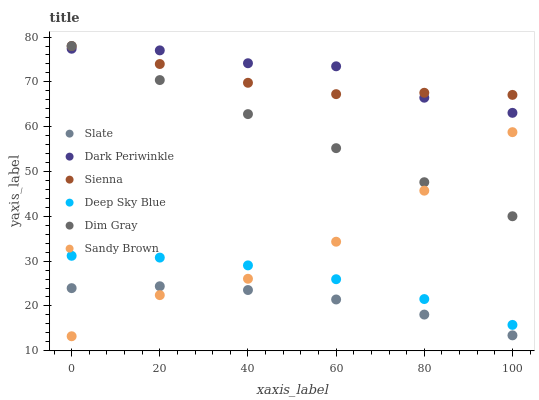Does Slate have the minimum area under the curve?
Answer yes or no. Yes. Does Dark Periwinkle have the maximum area under the curve?
Answer yes or no. Yes. Does Sienna have the minimum area under the curve?
Answer yes or no. No. Does Sienna have the maximum area under the curve?
Answer yes or no. No. Is Dim Gray the smoothest?
Answer yes or no. Yes. Is Sandy Brown the roughest?
Answer yes or no. Yes. Is Slate the smoothest?
Answer yes or no. No. Is Slate the roughest?
Answer yes or no. No. Does Sandy Brown have the lowest value?
Answer yes or no. Yes. Does Slate have the lowest value?
Answer yes or no. No. Does Sienna have the highest value?
Answer yes or no. Yes. Does Slate have the highest value?
Answer yes or no. No. Is Deep Sky Blue less than Dim Gray?
Answer yes or no. Yes. Is Sienna greater than Sandy Brown?
Answer yes or no. Yes. Does Dark Periwinkle intersect Sienna?
Answer yes or no. Yes. Is Dark Periwinkle less than Sienna?
Answer yes or no. No. Is Dark Periwinkle greater than Sienna?
Answer yes or no. No. Does Deep Sky Blue intersect Dim Gray?
Answer yes or no. No. 